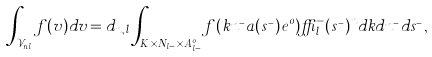Convert formula to latex. <formula><loc_0><loc_0><loc_500><loc_500>\int _ { { \mathcal { V } } _ { n , l } } f ( v ) d v = d _ { n , l } \int _ { K \times N _ { l - } \times A ^ { o } _ { l - } } f ( k n ^ { _ { - } } a ( s ^ { _ { - } } ) e ^ { 0 } ) \delta _ { l } ^ { - } ( s ^ { _ { - } } ) ^ { n } d k d n ^ { _ { - } } d s ^ { _ { - } } ,</formula> 